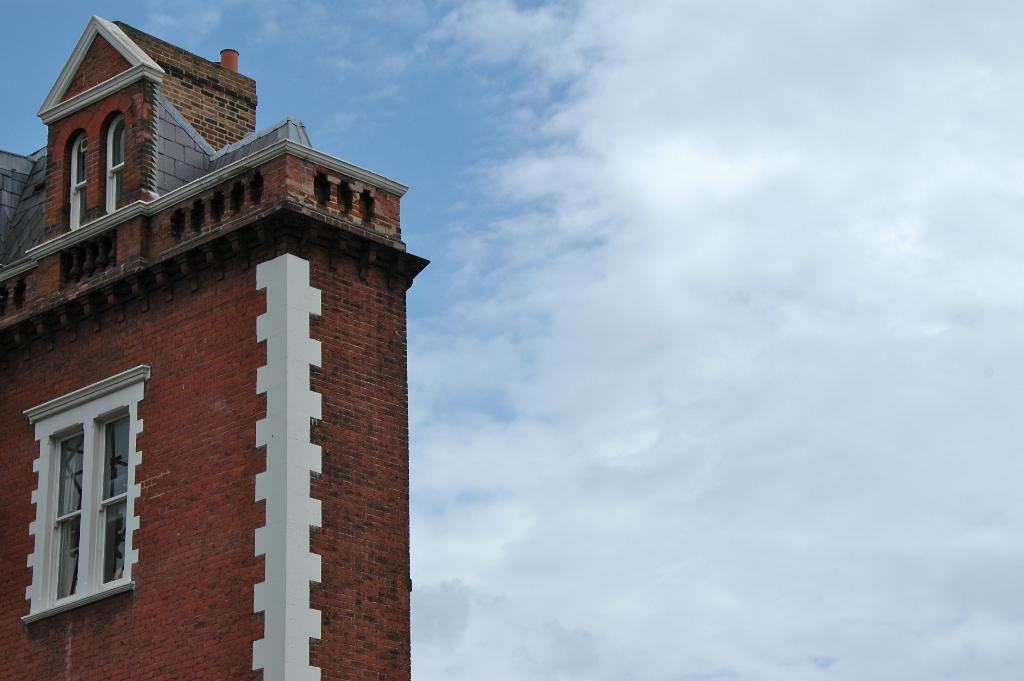What is the main subject of the picture? The main subject of the picture is a building. What specific features can be seen on the building? The building has windows. What can be seen in the background of the picture? The sky is visible in the background of the picture. What type of weather condition is suggested by the presence of clouds in the sky? The presence of clouds in the sky suggests that it might be partly cloudy or overcast. What type of hose is being used to water the copper chairs in the image? There is no hose or copper chairs present in the image; it features a building with windows and a sky with clouds. 